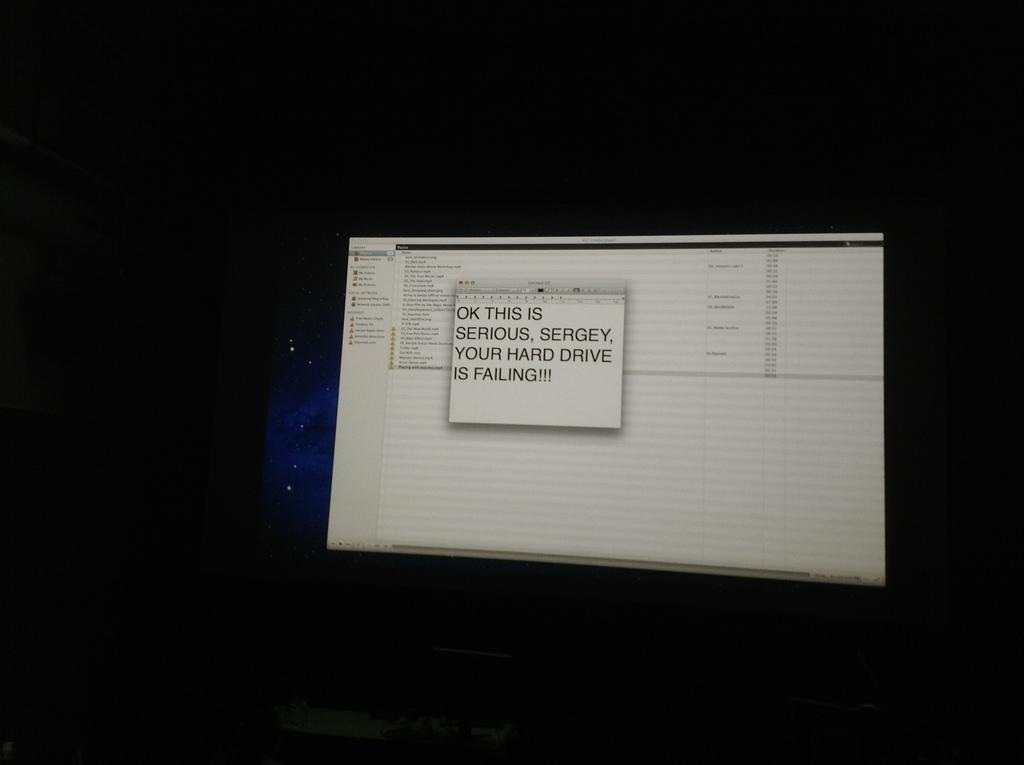<image>
Offer a succinct explanation of the picture presented. A pop up window displays a hard drive failure warning. 